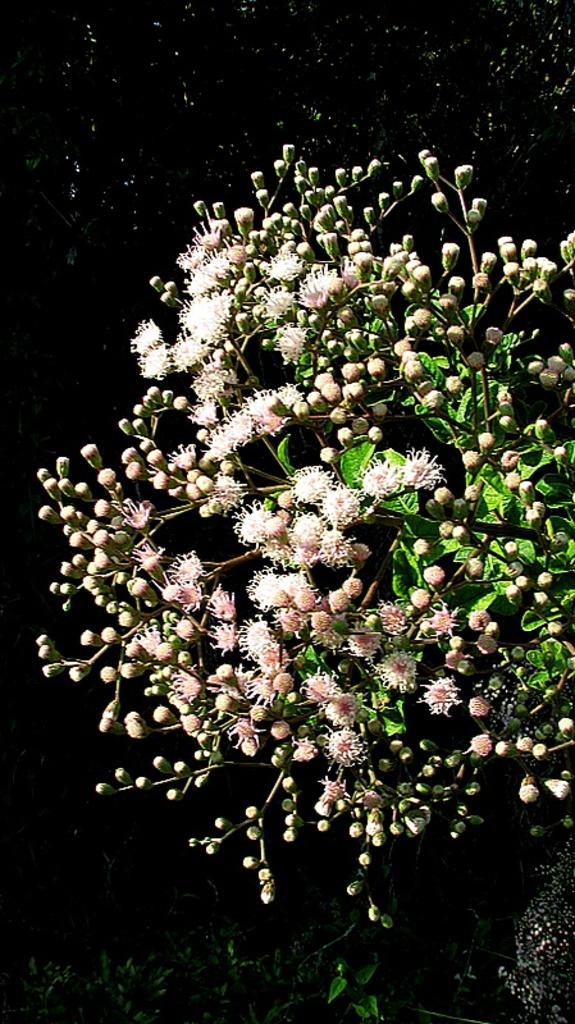What is present in the image? There is a plant in the image. What type of hat is the plant wearing in the image? There is no hat present in the image, as the subject is a plant and not a person or an object that could wear a hat. 